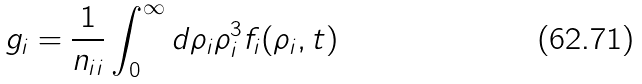<formula> <loc_0><loc_0><loc_500><loc_500>g _ { i } = \frac { 1 } { n _ { i i } } \int _ { 0 } ^ { \infty } d \rho _ { i } \rho _ { i } ^ { 3 } f _ { i } ( \rho _ { i } , t )</formula> 